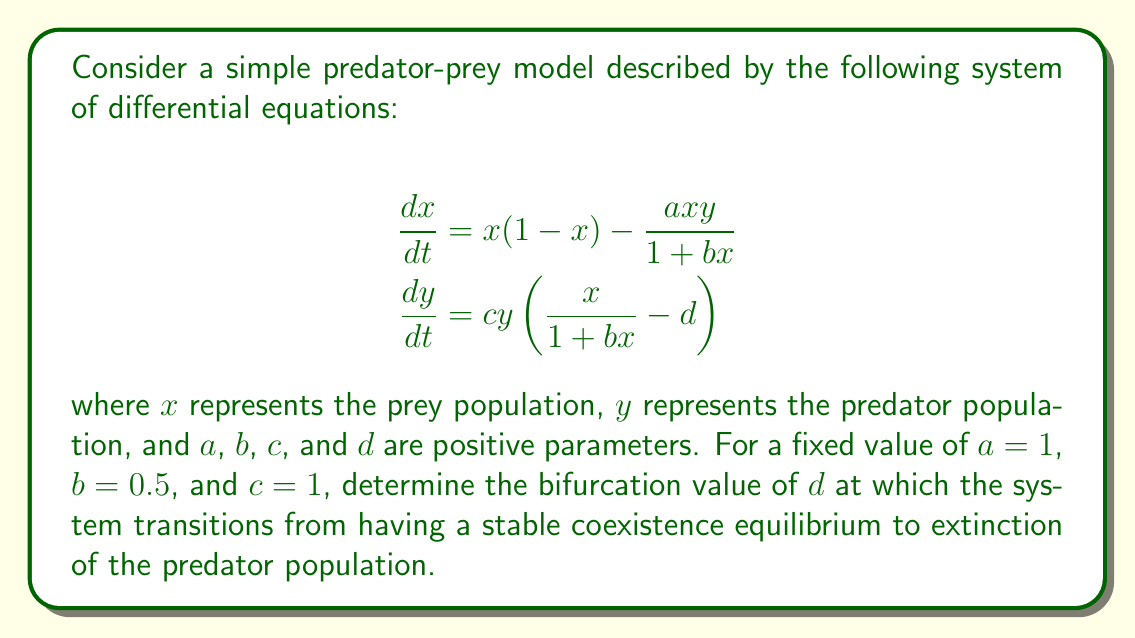Help me with this question. To solve this problem, we'll follow these steps:

1) First, we need to find the equilibrium points of the system. We do this by setting both equations to zero and solving for $x$ and $y$.

2) From the second equation, we can see that $y = 0$ (predator extinction) is always an equilibrium. For the coexistence equilibrium, we set:

   $$\frac{x}{1 + bx} - d = 0$$

3) Solving this equation for $x$, we get:

   $$x = \frac{d}{1 - bd}$$

4) For this equilibrium to be biologically meaningful, we need $x > 0$, which implies $d < \frac{1}{b}$.

5) Substituting this $x$ value into the first equation and setting it to zero:

   $$\frac{d}{1 - bd}\left(1 - \frac{d}{1 - bd}\right) - \frac{ay}{1 + b\frac{d}{1 - bd}} = 0$$

6) Solving for $y$, we get the coexistence equilibrium:

   $$\left(\frac{d}{1 - bd}, \frac{(1 - d)(1 - bd)^2}{a}\right)$$

7) The bifurcation occurs when this equilibrium coincides with the predator extinction equilibrium, i.e., when $y = 0$.

8) Setting $y = 0$ in the coexistence equilibrium:

   $$\frac{(1 - d)(1 - bd)^2}{a} = 0$$

9) Solving this equation (with $a = 1$ and $b = 0.5$ as given):

   $$(1 - d)(1 - 0.5d)^2 = 0$$

10) The solution to this equation is $d = 1$, which is our bifurcation value.

11) We can verify that this satisfies our earlier condition $d < \frac{1}{b} = 2$.

Therefore, the bifurcation value of $d$ is 1.
Answer: $d = 1$ 